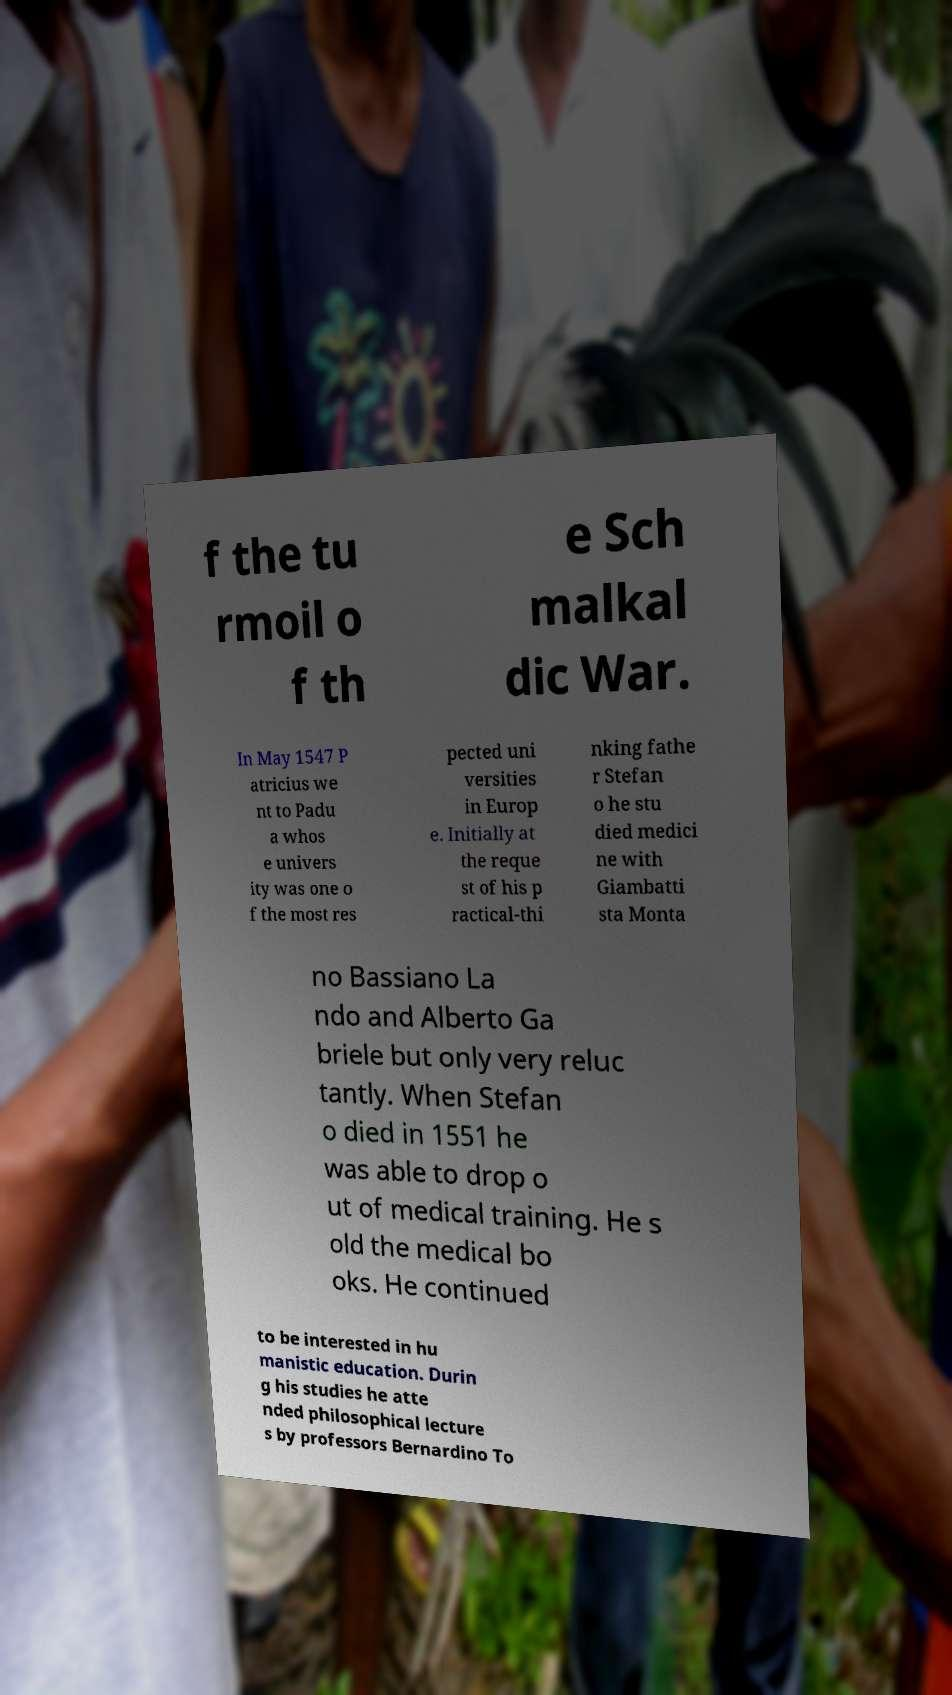Can you read and provide the text displayed in the image?This photo seems to have some interesting text. Can you extract and type it out for me? f the tu rmoil o f th e Sch malkal dic War. In May 1547 P atricius we nt to Padu a whos e univers ity was one o f the most res pected uni versities in Europ e. Initially at the reque st of his p ractical-thi nking fathe r Stefan o he stu died medici ne with Giambatti sta Monta no Bassiano La ndo and Alberto Ga briele but only very reluc tantly. When Stefan o died in 1551 he was able to drop o ut of medical training. He s old the medical bo oks. He continued to be interested in hu manistic education. Durin g his studies he atte nded philosophical lecture s by professors Bernardino To 